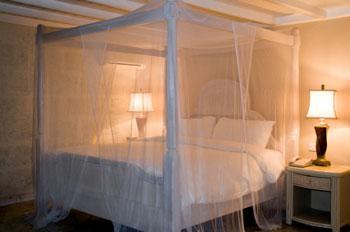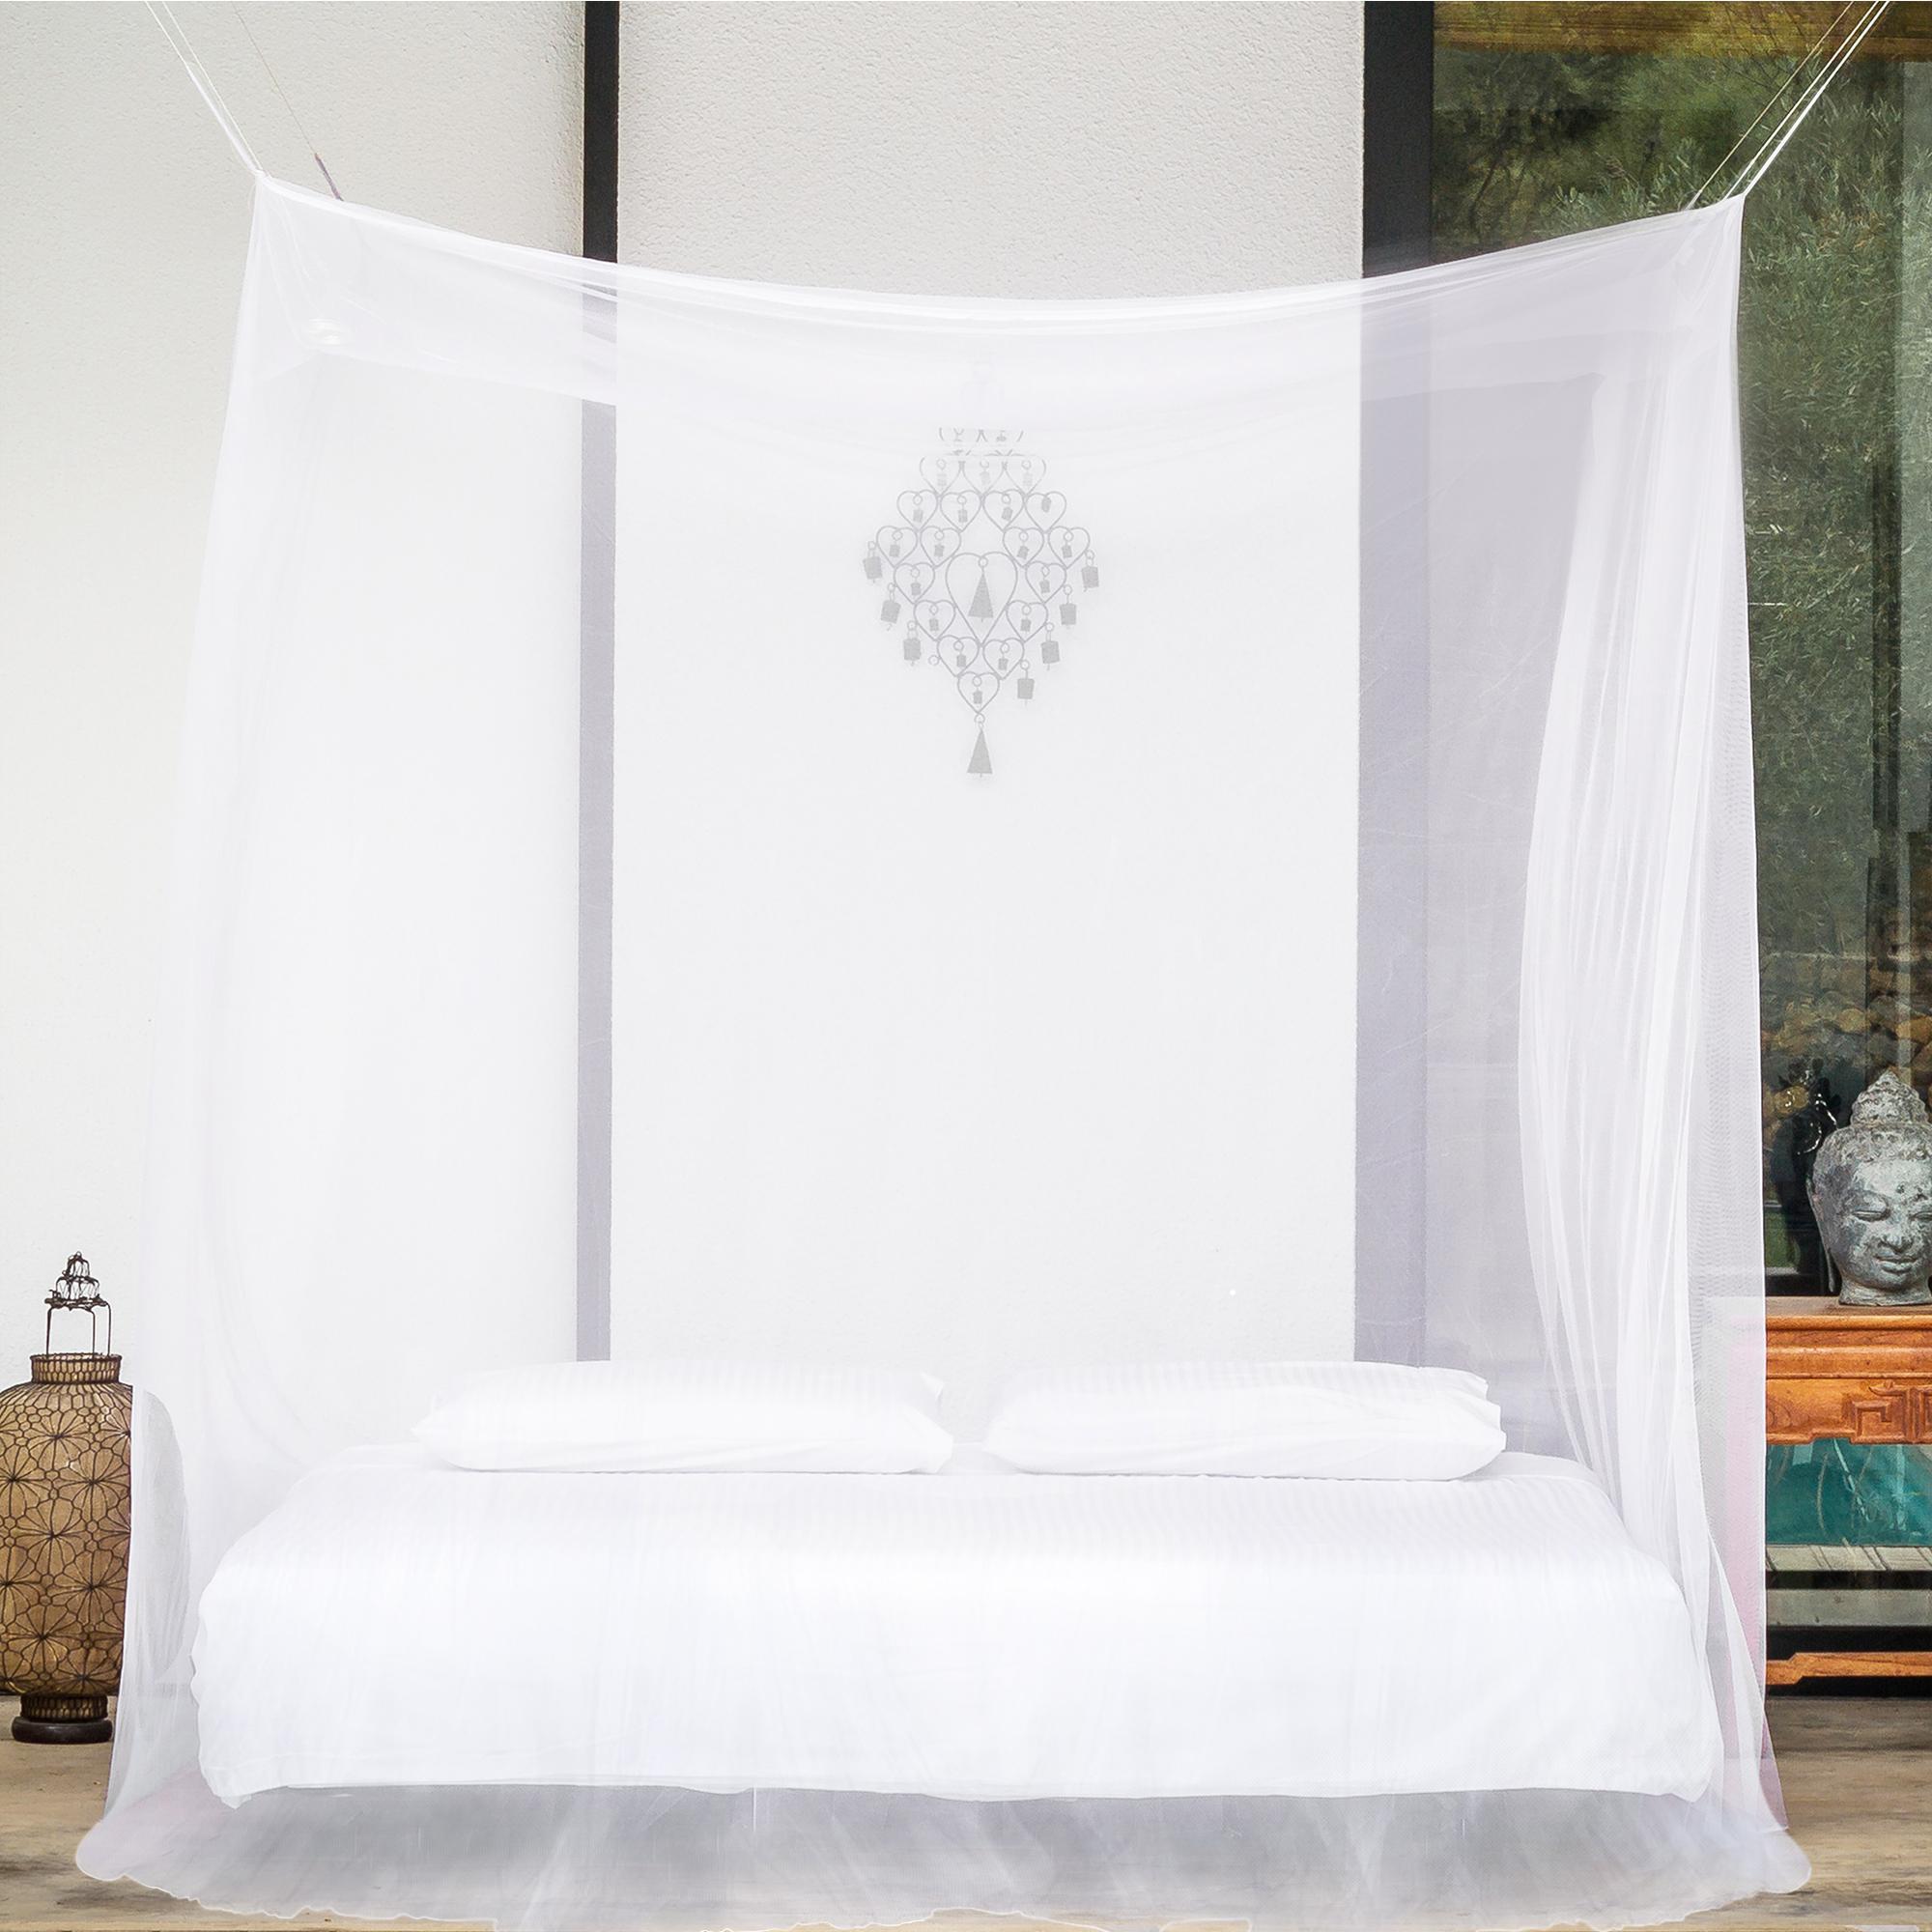The first image is the image on the left, the second image is the image on the right. Assess this claim about the two images: "Two or more humans are visible.". Correct or not? Answer yes or no. No. The first image is the image on the left, the second image is the image on the right. For the images displayed, is the sentence "There are two square canopies with at least two people near it." factually correct? Answer yes or no. No. 